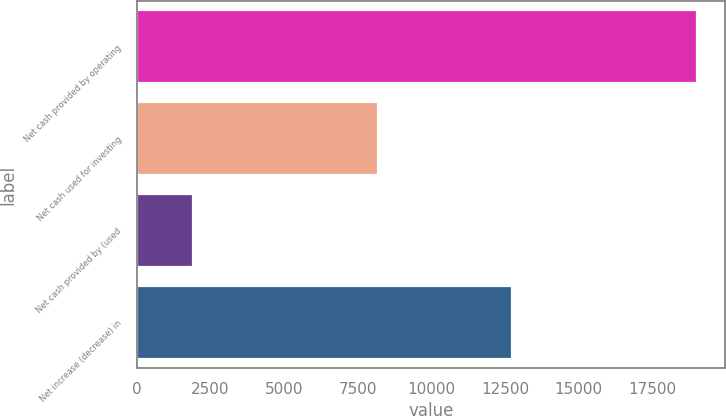Convert chart. <chart><loc_0><loc_0><loc_500><loc_500><bar_chart><fcel>Net cash provided by operating<fcel>Net cash used for investing<fcel>Net cash provided by (used<fcel>Net increase (decrease) in<nl><fcel>19018<fcel>8183<fcel>1912<fcel>12747<nl></chart> 